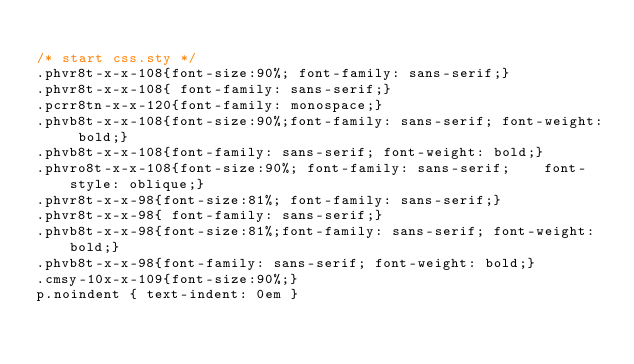Convert code to text. <code><loc_0><loc_0><loc_500><loc_500><_CSS_> 
/* start css.sty */
.phvr8t-x-x-108{font-size:90%; font-family: sans-serif;}
.phvr8t-x-x-108{ font-family: sans-serif;}
.pcrr8tn-x-x-120{font-family: monospace;}
.phvb8t-x-x-108{font-size:90%;font-family: sans-serif; font-weight: bold;}
.phvb8t-x-x-108{font-family: sans-serif; font-weight: bold;}
.phvro8t-x-x-108{font-size:90%; font-family: sans-serif;    font-style: oblique;}
.phvr8t-x-x-98{font-size:81%; font-family: sans-serif;}
.phvr8t-x-x-98{ font-family: sans-serif;}
.phvb8t-x-x-98{font-size:81%;font-family: sans-serif; font-weight: bold;}
.phvb8t-x-x-98{font-family: sans-serif; font-weight: bold;}
.cmsy-10x-x-109{font-size:90%;}
p.noindent { text-indent: 0em }</code> 